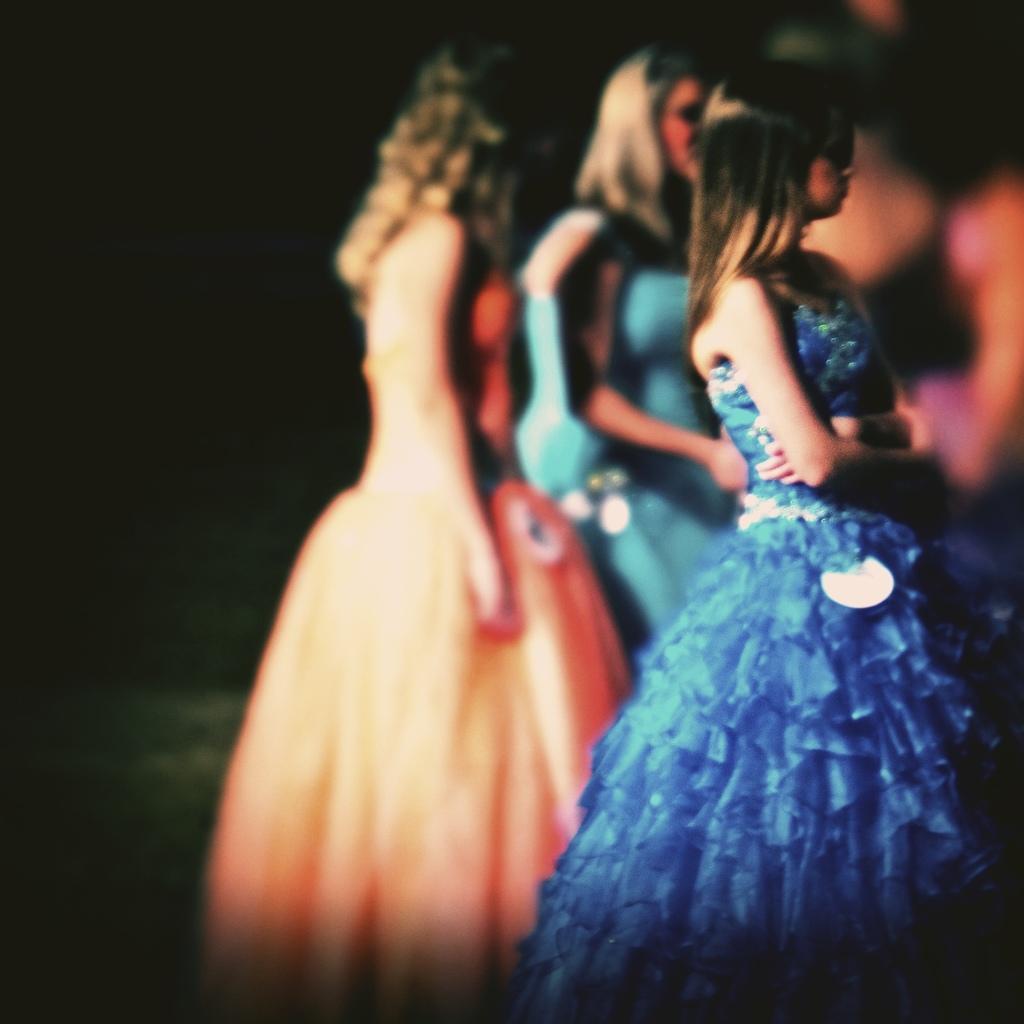Could you give a brief overview of what you see in this image? In this image we can see a few people standing and the background is dark. 